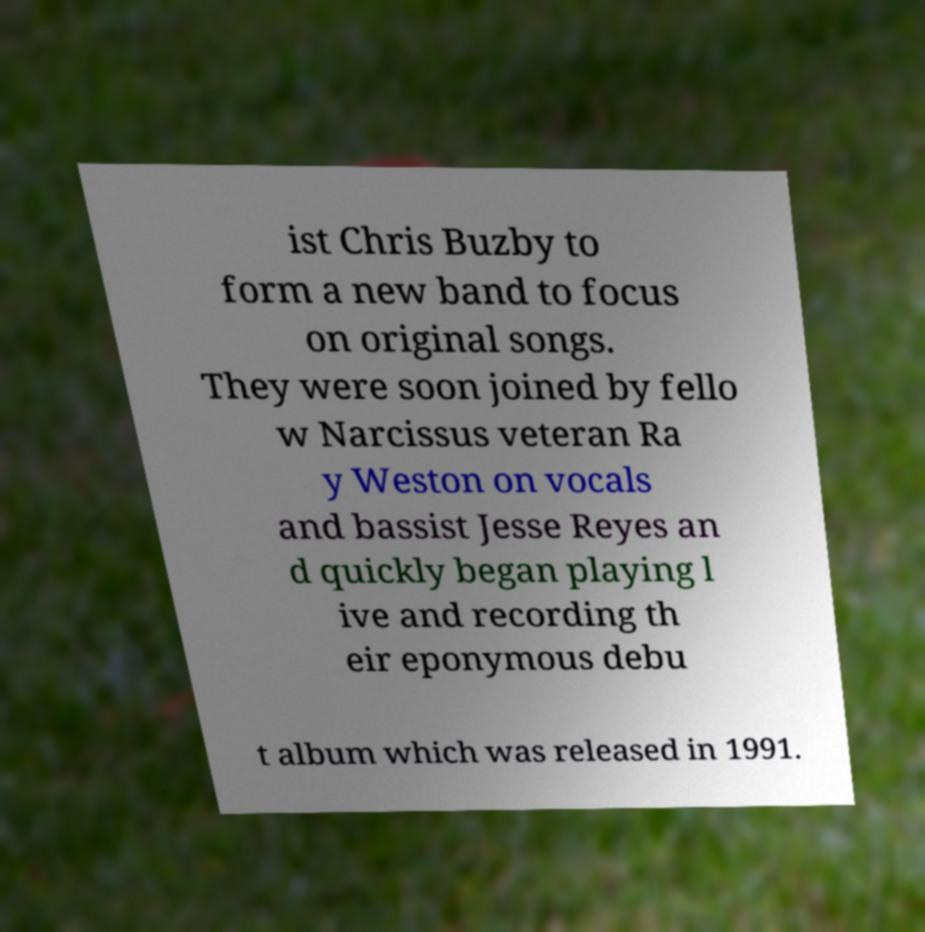There's text embedded in this image that I need extracted. Can you transcribe it verbatim? ist Chris Buzby to form a new band to focus on original songs. They were soon joined by fello w Narcissus veteran Ra y Weston on vocals and bassist Jesse Reyes an d quickly began playing l ive and recording th eir eponymous debu t album which was released in 1991. 